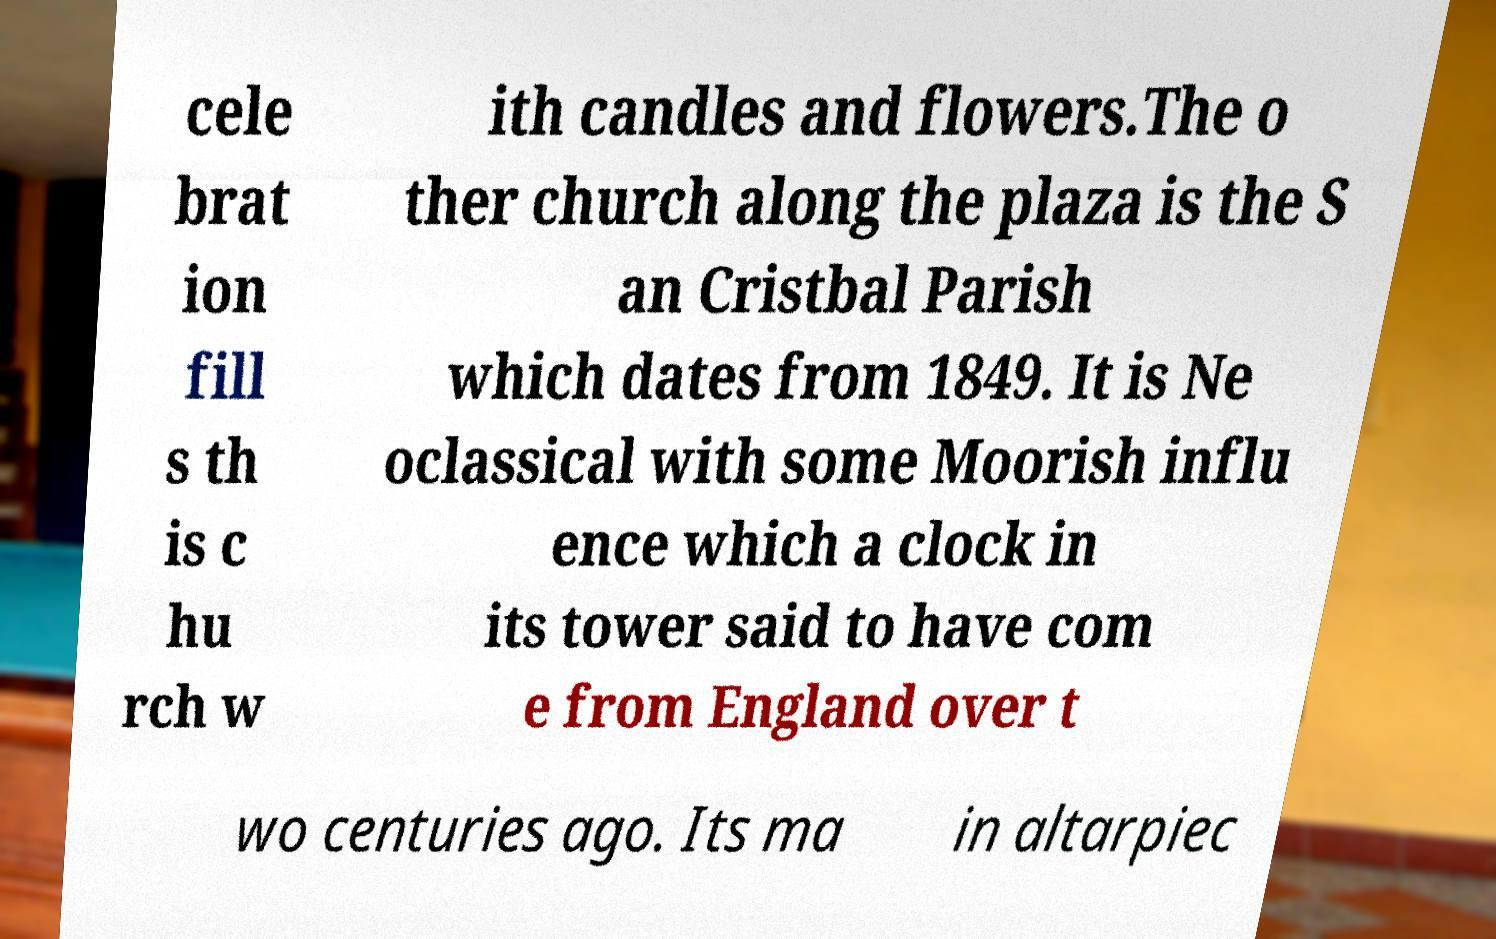Please identify and transcribe the text found in this image. cele brat ion fill s th is c hu rch w ith candles and flowers.The o ther church along the plaza is the S an Cristbal Parish which dates from 1849. It is Ne oclassical with some Moorish influ ence which a clock in its tower said to have com e from England over t wo centuries ago. Its ma in altarpiec 